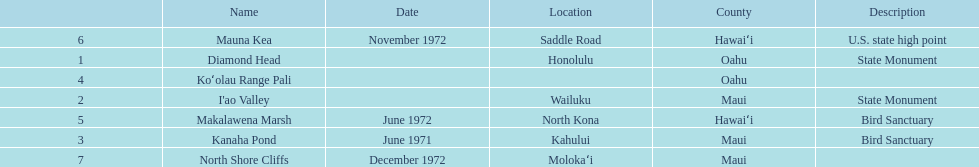What is the total number of state monuments? 2. 